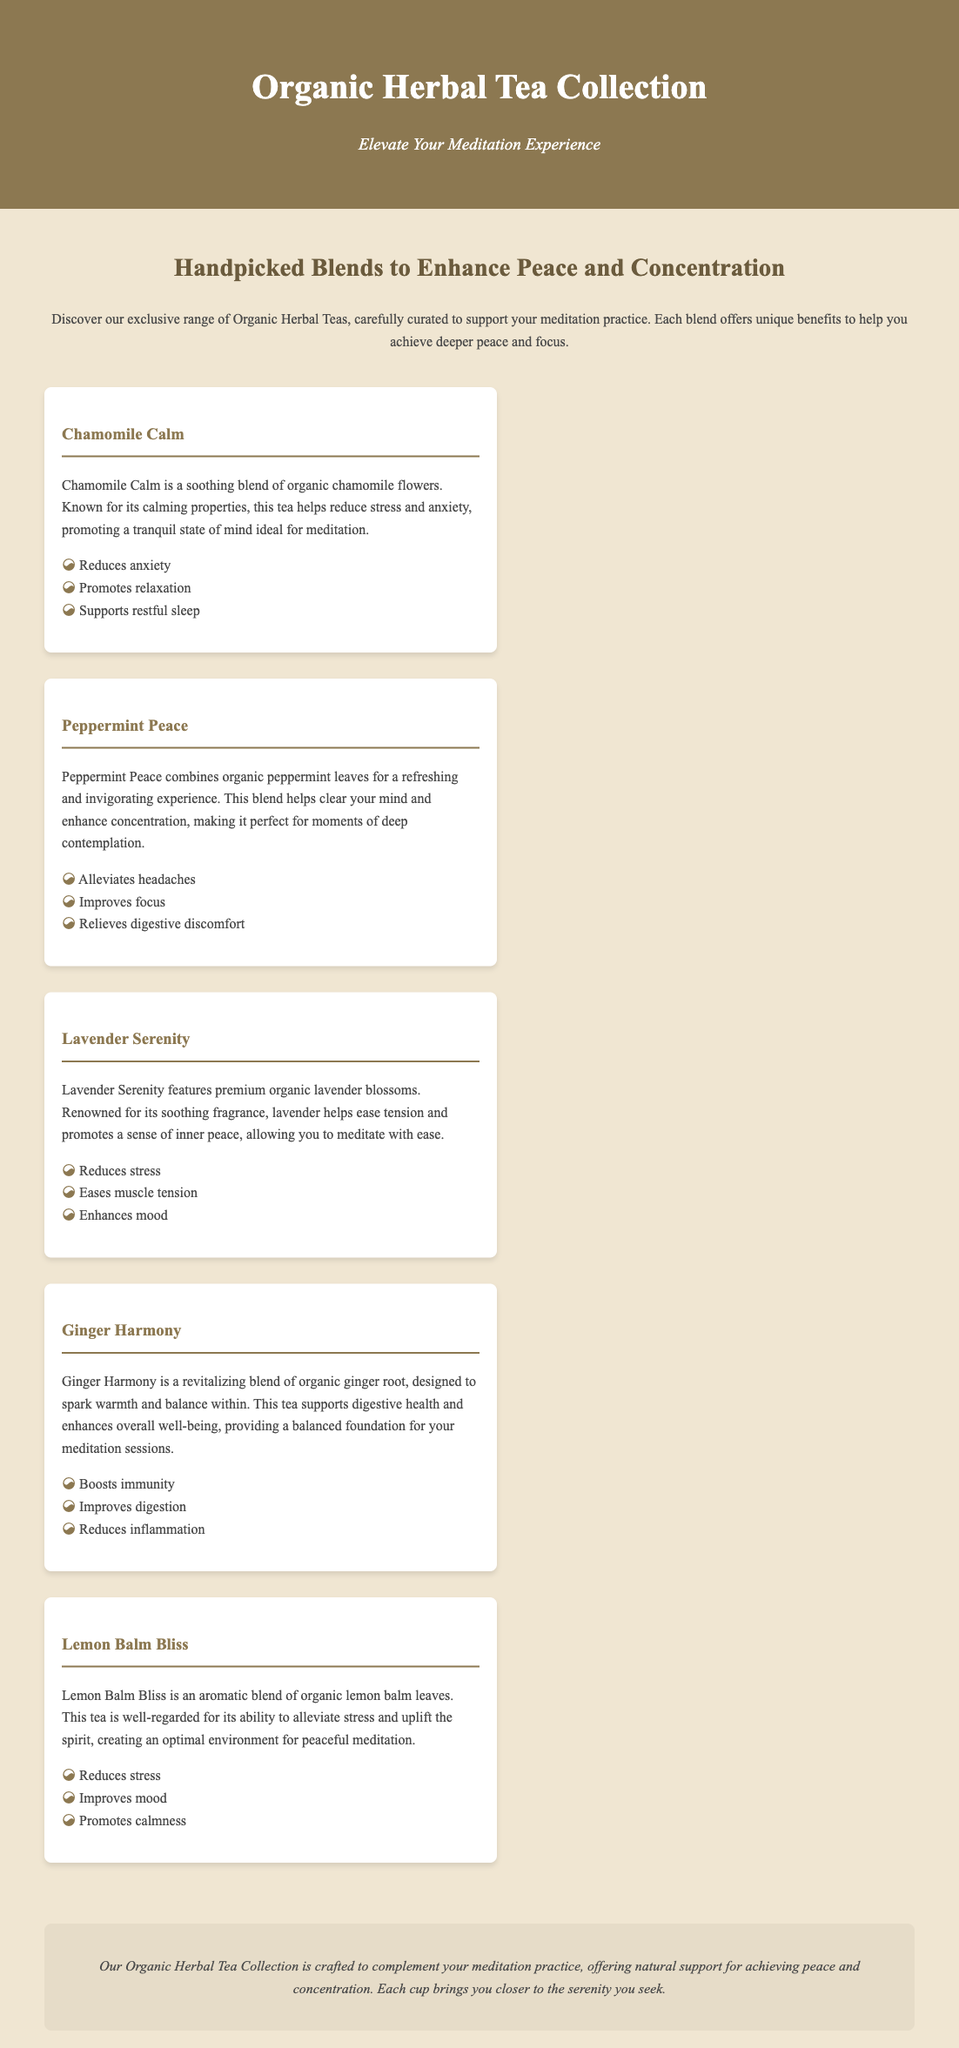What is the title of the collection? The title is prominently displayed at the top of the document, indicating the product being offered.
Answer: Organic Herbal Tea Collection How many tea blends are featured? The document lists five distinct tea blends, each with unique benefits.
Answer: Five What is one benefit of Chamomile Calm? The benefits of Chamomile Calm are listed in bullet points under its description.
Answer: Reduces anxiety Which blend is known for its refreshing experience? The description highlights the invigorating qualities of one specific blend.
Answer: Peppermint Peace What ingredient is used in Ginger Harmony? The primary ingredient of the Ginger Harmony blend is indicated in its description.
Answer: Organic ginger root What does Lavender Serenity promote? The benefits of Lavender Serenity are outlined, emphasizing its effects on the mind.
Answer: Inner peace Which tea blend is associated with uplifting the spirit? The document specifically states the properties of this particular tea blend.
Answer: Lemon Balm Bliss What calming effect does Lavender Serenity have? The benefits listed for Lavender Serenity include several calming effects.
Answer: Eases muscle tension What is the purpose of the Organic Herbal Tea Collection? The purpose is stated clearly in the introductory paragraph of the document.
Answer: To complement your meditation practice 